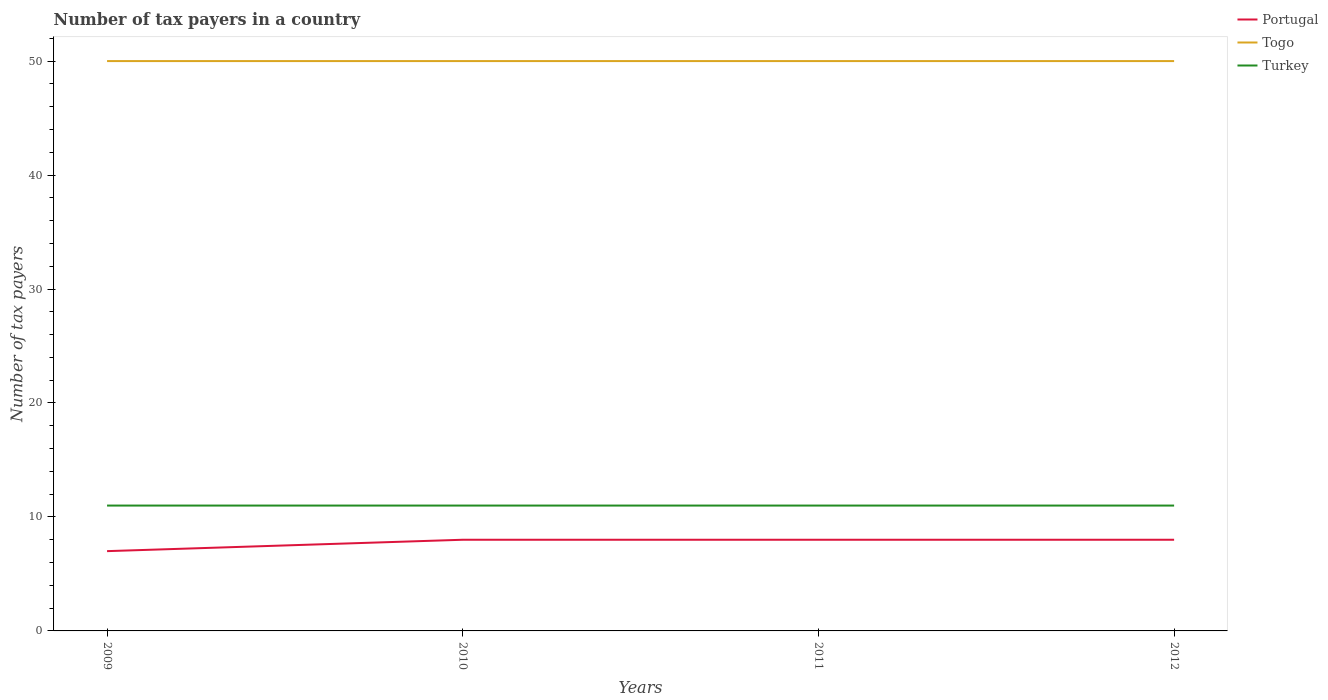How many different coloured lines are there?
Give a very brief answer. 3. Is the number of lines equal to the number of legend labels?
Make the answer very short. Yes. Across all years, what is the maximum number of tax payers in in Portugal?
Your response must be concise. 7. In which year was the number of tax payers in in Turkey maximum?
Provide a succinct answer. 2009. What is the total number of tax payers in in Togo in the graph?
Offer a very short reply. 0. What is the difference between the highest and the second highest number of tax payers in in Turkey?
Keep it short and to the point. 0. Is the number of tax payers in in Togo strictly greater than the number of tax payers in in Turkey over the years?
Give a very brief answer. No. What is the difference between two consecutive major ticks on the Y-axis?
Provide a succinct answer. 10. Are the values on the major ticks of Y-axis written in scientific E-notation?
Provide a short and direct response. No. Does the graph contain grids?
Your answer should be compact. No. How many legend labels are there?
Your response must be concise. 3. What is the title of the graph?
Make the answer very short. Number of tax payers in a country. What is the label or title of the Y-axis?
Give a very brief answer. Number of tax payers. What is the Number of tax payers in Turkey in 2009?
Your response must be concise. 11. What is the Number of tax payers in Portugal in 2010?
Offer a terse response. 8. What is the Number of tax payers in Togo in 2010?
Offer a very short reply. 50. What is the Number of tax payers in Portugal in 2011?
Your response must be concise. 8. What is the Number of tax payers in Togo in 2011?
Offer a very short reply. 50. What is the Number of tax payers of Portugal in 2012?
Offer a terse response. 8. What is the Number of tax payers of Togo in 2012?
Offer a terse response. 50. What is the Number of tax payers of Turkey in 2012?
Provide a short and direct response. 11. Across all years, what is the maximum Number of tax payers in Togo?
Your answer should be compact. 50. Across all years, what is the minimum Number of tax payers in Portugal?
Provide a succinct answer. 7. What is the difference between the Number of tax payers in Turkey in 2009 and that in 2010?
Make the answer very short. 0. What is the difference between the Number of tax payers in Portugal in 2009 and that in 2011?
Offer a very short reply. -1. What is the difference between the Number of tax payers of Togo in 2009 and that in 2012?
Make the answer very short. 0. What is the difference between the Number of tax payers of Portugal in 2010 and that in 2011?
Provide a succinct answer. 0. What is the difference between the Number of tax payers in Togo in 2010 and that in 2011?
Provide a succinct answer. 0. What is the difference between the Number of tax payers of Portugal in 2010 and that in 2012?
Give a very brief answer. 0. What is the difference between the Number of tax payers of Turkey in 2010 and that in 2012?
Keep it short and to the point. 0. What is the difference between the Number of tax payers in Portugal in 2011 and that in 2012?
Offer a terse response. 0. What is the difference between the Number of tax payers in Turkey in 2011 and that in 2012?
Offer a very short reply. 0. What is the difference between the Number of tax payers of Portugal in 2009 and the Number of tax payers of Togo in 2010?
Your response must be concise. -43. What is the difference between the Number of tax payers in Portugal in 2009 and the Number of tax payers in Turkey in 2010?
Keep it short and to the point. -4. What is the difference between the Number of tax payers in Portugal in 2009 and the Number of tax payers in Togo in 2011?
Keep it short and to the point. -43. What is the difference between the Number of tax payers in Portugal in 2009 and the Number of tax payers in Togo in 2012?
Keep it short and to the point. -43. What is the difference between the Number of tax payers in Portugal in 2010 and the Number of tax payers in Togo in 2011?
Keep it short and to the point. -42. What is the difference between the Number of tax payers of Portugal in 2010 and the Number of tax payers of Togo in 2012?
Your response must be concise. -42. What is the difference between the Number of tax payers of Portugal in 2011 and the Number of tax payers of Togo in 2012?
Your answer should be compact. -42. What is the difference between the Number of tax payers of Portugal in 2011 and the Number of tax payers of Turkey in 2012?
Keep it short and to the point. -3. What is the difference between the Number of tax payers of Togo in 2011 and the Number of tax payers of Turkey in 2012?
Ensure brevity in your answer.  39. What is the average Number of tax payers in Portugal per year?
Provide a short and direct response. 7.75. What is the average Number of tax payers of Togo per year?
Ensure brevity in your answer.  50. What is the average Number of tax payers of Turkey per year?
Offer a very short reply. 11. In the year 2009, what is the difference between the Number of tax payers in Portugal and Number of tax payers in Togo?
Make the answer very short. -43. In the year 2009, what is the difference between the Number of tax payers of Portugal and Number of tax payers of Turkey?
Offer a very short reply. -4. In the year 2009, what is the difference between the Number of tax payers in Togo and Number of tax payers in Turkey?
Offer a very short reply. 39. In the year 2010, what is the difference between the Number of tax payers of Portugal and Number of tax payers of Togo?
Ensure brevity in your answer.  -42. In the year 2011, what is the difference between the Number of tax payers of Portugal and Number of tax payers of Togo?
Give a very brief answer. -42. In the year 2012, what is the difference between the Number of tax payers in Portugal and Number of tax payers in Togo?
Ensure brevity in your answer.  -42. In the year 2012, what is the difference between the Number of tax payers in Portugal and Number of tax payers in Turkey?
Give a very brief answer. -3. In the year 2012, what is the difference between the Number of tax payers of Togo and Number of tax payers of Turkey?
Make the answer very short. 39. What is the ratio of the Number of tax payers in Togo in 2009 to that in 2010?
Offer a very short reply. 1. What is the ratio of the Number of tax payers in Turkey in 2009 to that in 2010?
Give a very brief answer. 1. What is the ratio of the Number of tax payers in Portugal in 2009 to that in 2011?
Your response must be concise. 0.88. What is the ratio of the Number of tax payers in Togo in 2009 to that in 2011?
Offer a very short reply. 1. What is the ratio of the Number of tax payers of Turkey in 2009 to that in 2011?
Provide a succinct answer. 1. What is the ratio of the Number of tax payers in Portugal in 2010 to that in 2011?
Offer a terse response. 1. What is the ratio of the Number of tax payers in Togo in 2010 to that in 2011?
Your response must be concise. 1. What is the ratio of the Number of tax payers in Togo in 2010 to that in 2012?
Offer a very short reply. 1. What is the ratio of the Number of tax payers in Turkey in 2010 to that in 2012?
Ensure brevity in your answer.  1. What is the ratio of the Number of tax payers of Portugal in 2011 to that in 2012?
Your response must be concise. 1. What is the difference between the highest and the second highest Number of tax payers in Portugal?
Make the answer very short. 0. What is the difference between the highest and the second highest Number of tax payers in Togo?
Your response must be concise. 0. What is the difference between the highest and the lowest Number of tax payers of Togo?
Your answer should be compact. 0. 